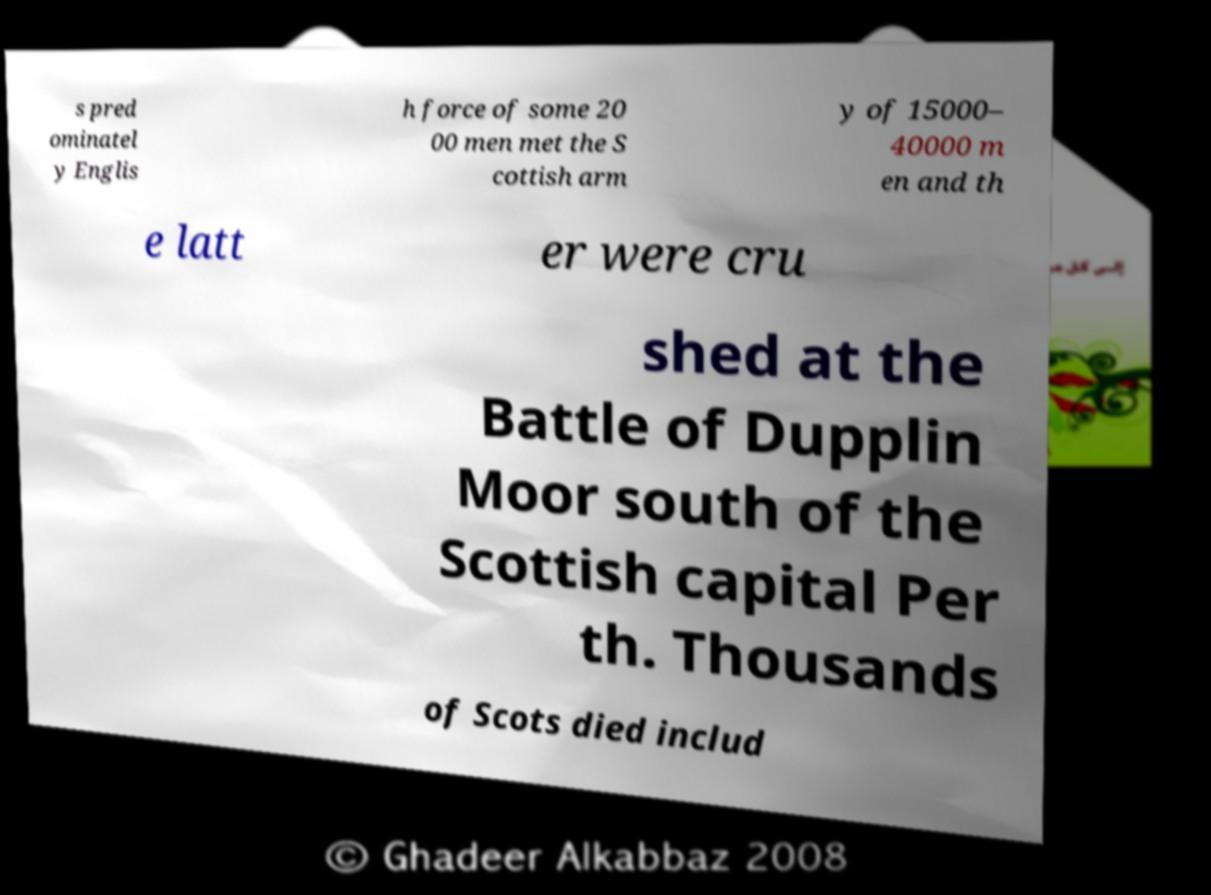There's text embedded in this image that I need extracted. Can you transcribe it verbatim? s pred ominatel y Englis h force of some 20 00 men met the S cottish arm y of 15000– 40000 m en and th e latt er were cru shed at the Battle of Dupplin Moor south of the Scottish capital Per th. Thousands of Scots died includ 